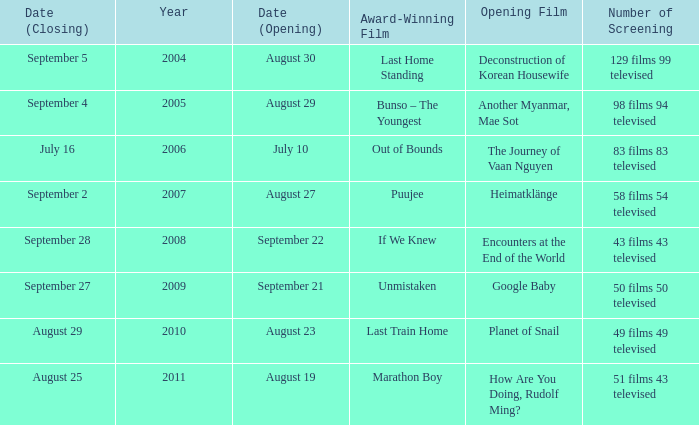Which opening film has the opening date of august 23? Planet of Snail. 